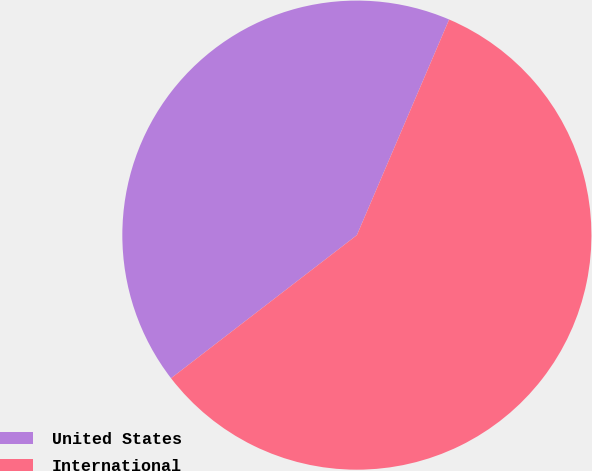Convert chart to OTSL. <chart><loc_0><loc_0><loc_500><loc_500><pie_chart><fcel>United States<fcel>International<nl><fcel>41.88%<fcel>58.12%<nl></chart> 